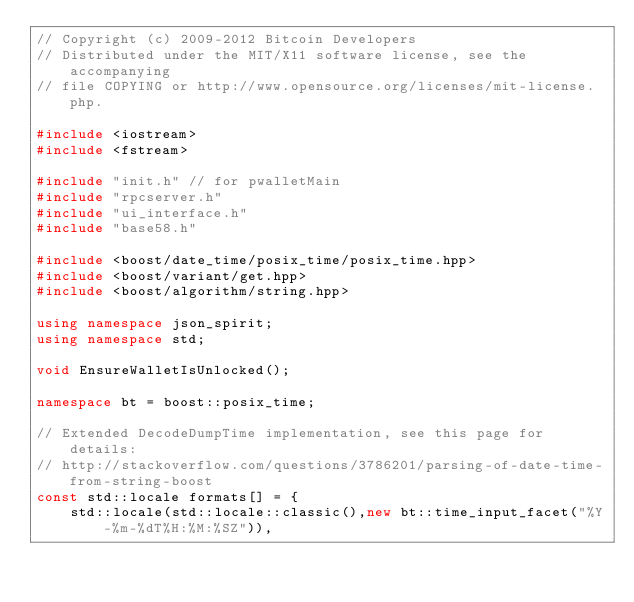Convert code to text. <code><loc_0><loc_0><loc_500><loc_500><_C++_>// Copyright (c) 2009-2012 Bitcoin Developers
// Distributed under the MIT/X11 software license, see the accompanying
// file COPYING or http://www.opensource.org/licenses/mit-license.php.

#include <iostream>
#include <fstream>

#include "init.h" // for pwalletMain
#include "rpcserver.h"
#include "ui_interface.h"
#include "base58.h"

#include <boost/date_time/posix_time/posix_time.hpp>
#include <boost/variant/get.hpp>
#include <boost/algorithm/string.hpp>

using namespace json_spirit;
using namespace std;

void EnsureWalletIsUnlocked();

namespace bt = boost::posix_time;

// Extended DecodeDumpTime implementation, see this page for details:
// http://stackoverflow.com/questions/3786201/parsing-of-date-time-from-string-boost
const std::locale formats[] = {
    std::locale(std::locale::classic(),new bt::time_input_facet("%Y-%m-%dT%H:%M:%SZ")),</code> 